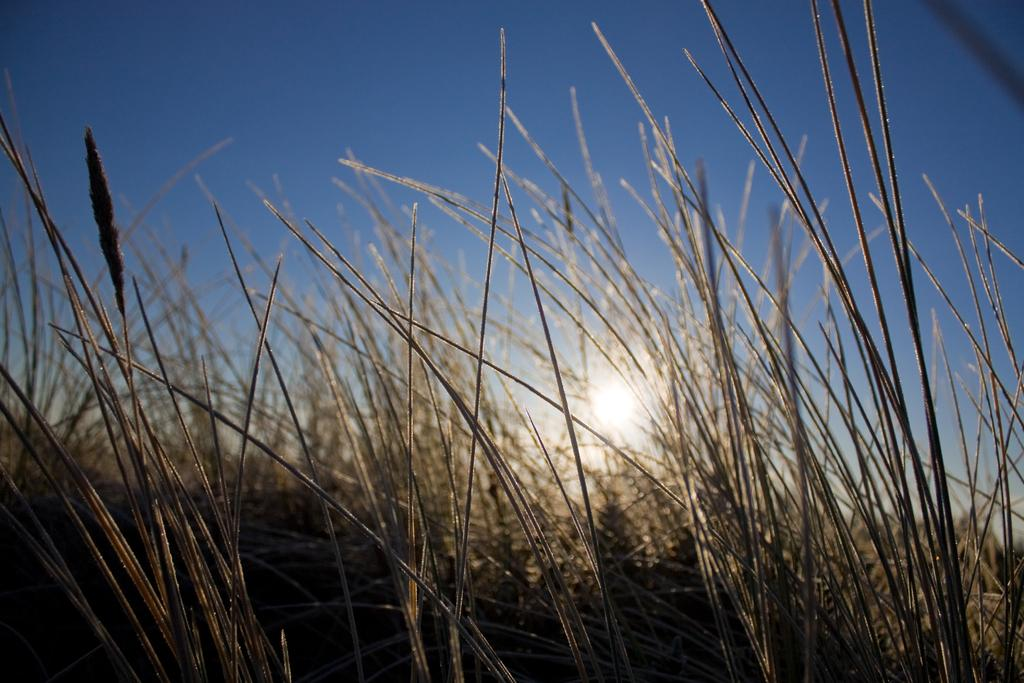What is on the ground in the image? There are plants on the ground. What color is the sky in the background? The sky is blue in the background. What celestial body can be seen in the blue sky? The sun is visible in the blue sky. What type of statement can be seen written on the plants in the image? There are no statements written on the plants in the image. What role does the brake play in the image? There is no brake present in the image. 